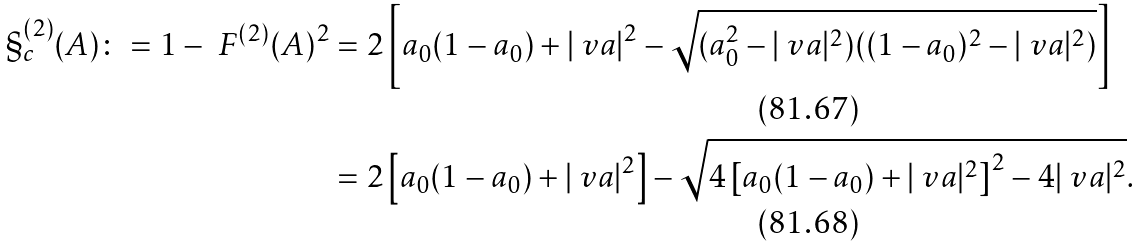Convert formula to latex. <formula><loc_0><loc_0><loc_500><loc_500>\S _ { c } ^ { ( 2 ) } ( A ) \colon = 1 - \ F ^ { ( 2 ) } ( A ) ^ { 2 } & = 2 \left [ a _ { 0 } ( 1 - a _ { 0 } ) + | \ v a | ^ { 2 } - \sqrt { ( a _ { 0 } ^ { 2 } - | \ v a | ^ { 2 } ) ( ( 1 - a _ { 0 } ) ^ { 2 } - | \ v a | ^ { 2 } ) } \right ] \\ & = 2 \left [ a _ { 0 } ( 1 - a _ { 0 } ) + | \ v a | ^ { 2 } \right ] - \sqrt { 4 \left [ a _ { 0 } ( 1 - a _ { 0 } ) + | \ v a | ^ { 2 } \right ] ^ { 2 } - 4 | \ v a | ^ { 2 } } .</formula> 